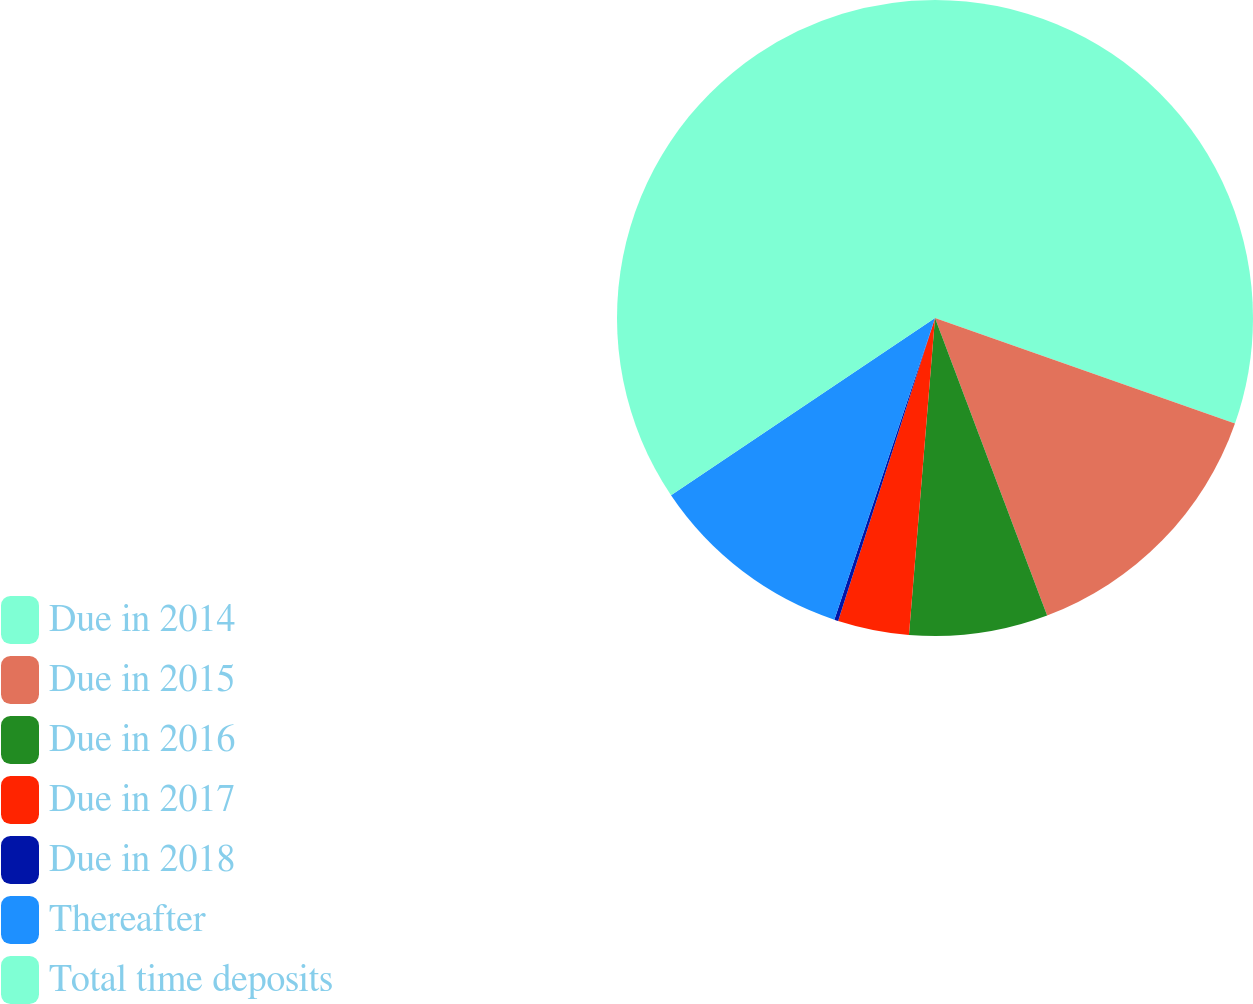<chart> <loc_0><loc_0><loc_500><loc_500><pie_chart><fcel>Due in 2014<fcel>Due in 2015<fcel>Due in 2016<fcel>Due in 2017<fcel>Due in 2018<fcel>Thereafter<fcel>Total time deposits<nl><fcel>30.38%<fcel>13.88%<fcel>7.04%<fcel>3.62%<fcel>0.2%<fcel>10.46%<fcel>34.41%<nl></chart> 